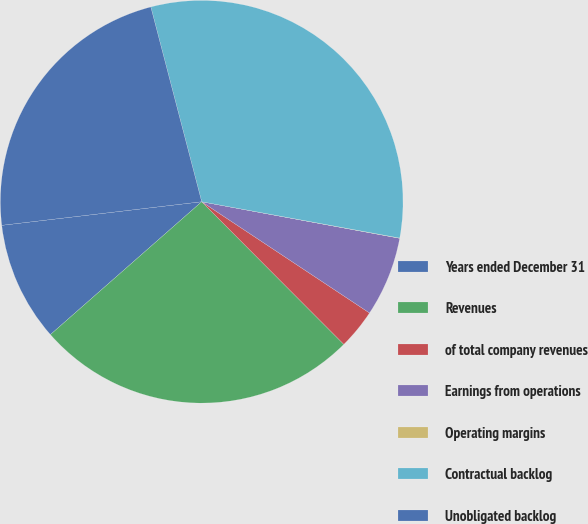<chart> <loc_0><loc_0><loc_500><loc_500><pie_chart><fcel>Years ended December 31<fcel>Revenues<fcel>of total company revenues<fcel>Earnings from operations<fcel>Operating margins<fcel>Contractual backlog<fcel>Unobligated backlog<nl><fcel>9.6%<fcel>26.0%<fcel>3.21%<fcel>6.41%<fcel>0.02%<fcel>31.95%<fcel>22.8%<nl></chart> 